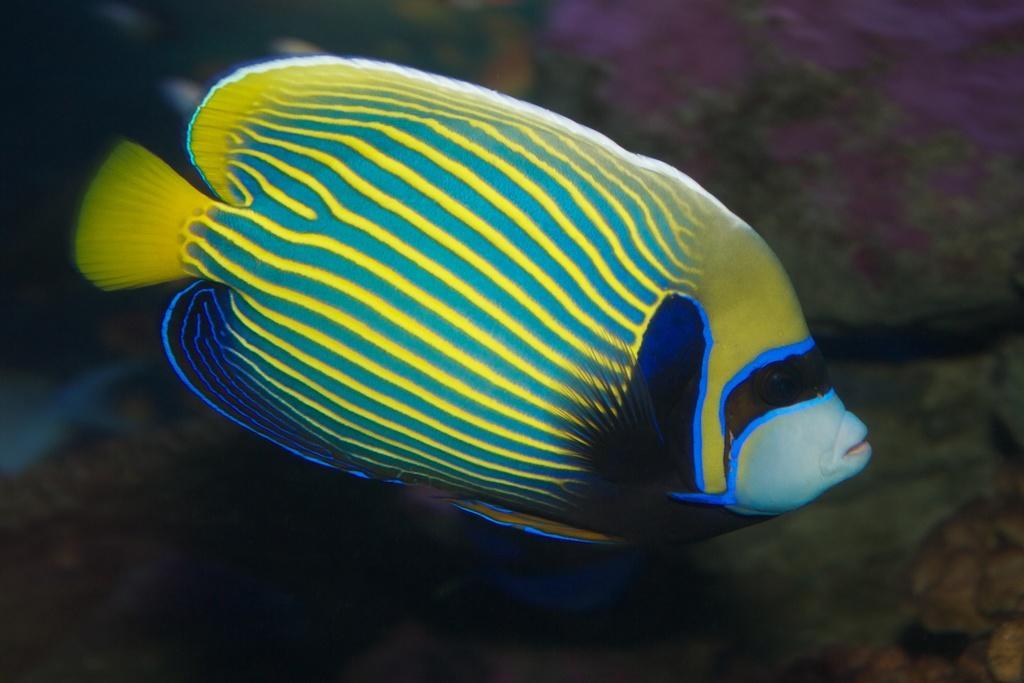Can you describe this image briefly? In this image, we can see a fish in the water. 